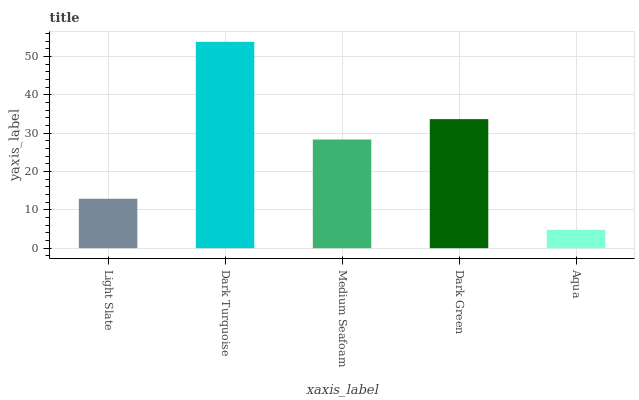Is Aqua the minimum?
Answer yes or no. Yes. Is Dark Turquoise the maximum?
Answer yes or no. Yes. Is Medium Seafoam the minimum?
Answer yes or no. No. Is Medium Seafoam the maximum?
Answer yes or no. No. Is Dark Turquoise greater than Medium Seafoam?
Answer yes or no. Yes. Is Medium Seafoam less than Dark Turquoise?
Answer yes or no. Yes. Is Medium Seafoam greater than Dark Turquoise?
Answer yes or no. No. Is Dark Turquoise less than Medium Seafoam?
Answer yes or no. No. Is Medium Seafoam the high median?
Answer yes or no. Yes. Is Medium Seafoam the low median?
Answer yes or no. Yes. Is Light Slate the high median?
Answer yes or no. No. Is Dark Green the low median?
Answer yes or no. No. 